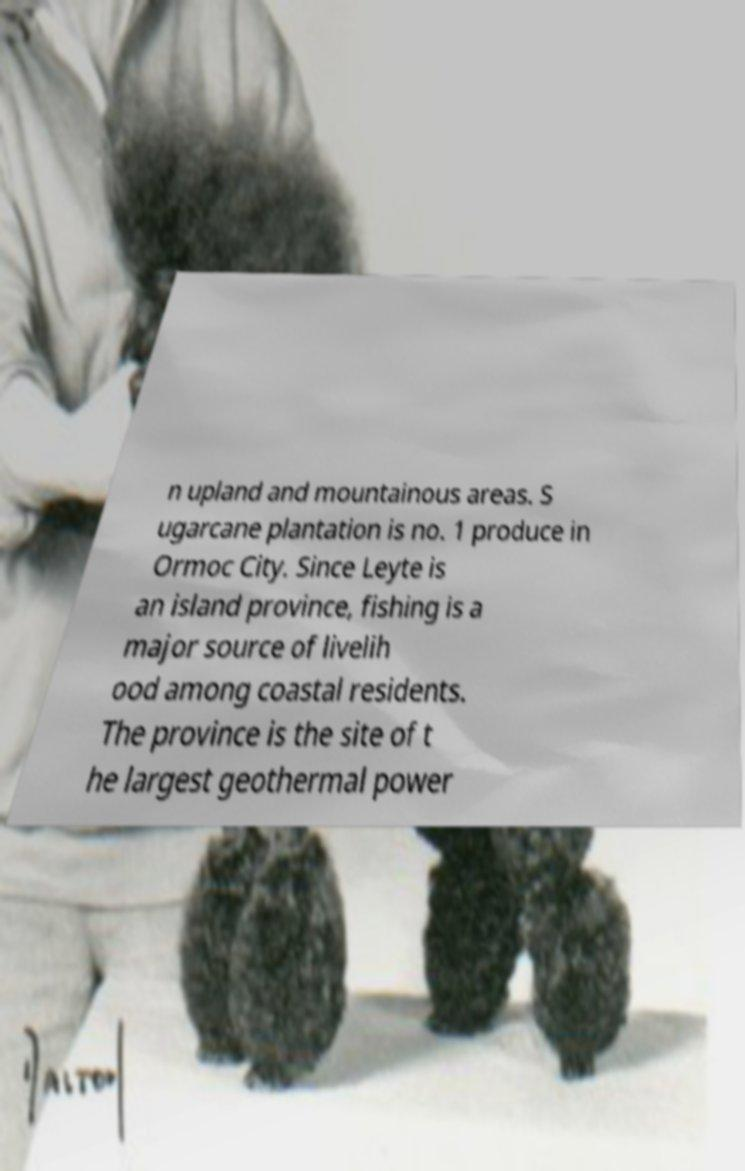Please read and relay the text visible in this image. What does it say? n upland and mountainous areas. S ugarcane plantation is no. 1 produce in Ormoc City. Since Leyte is an island province, fishing is a major source of livelih ood among coastal residents. The province is the site of t he largest geothermal power 